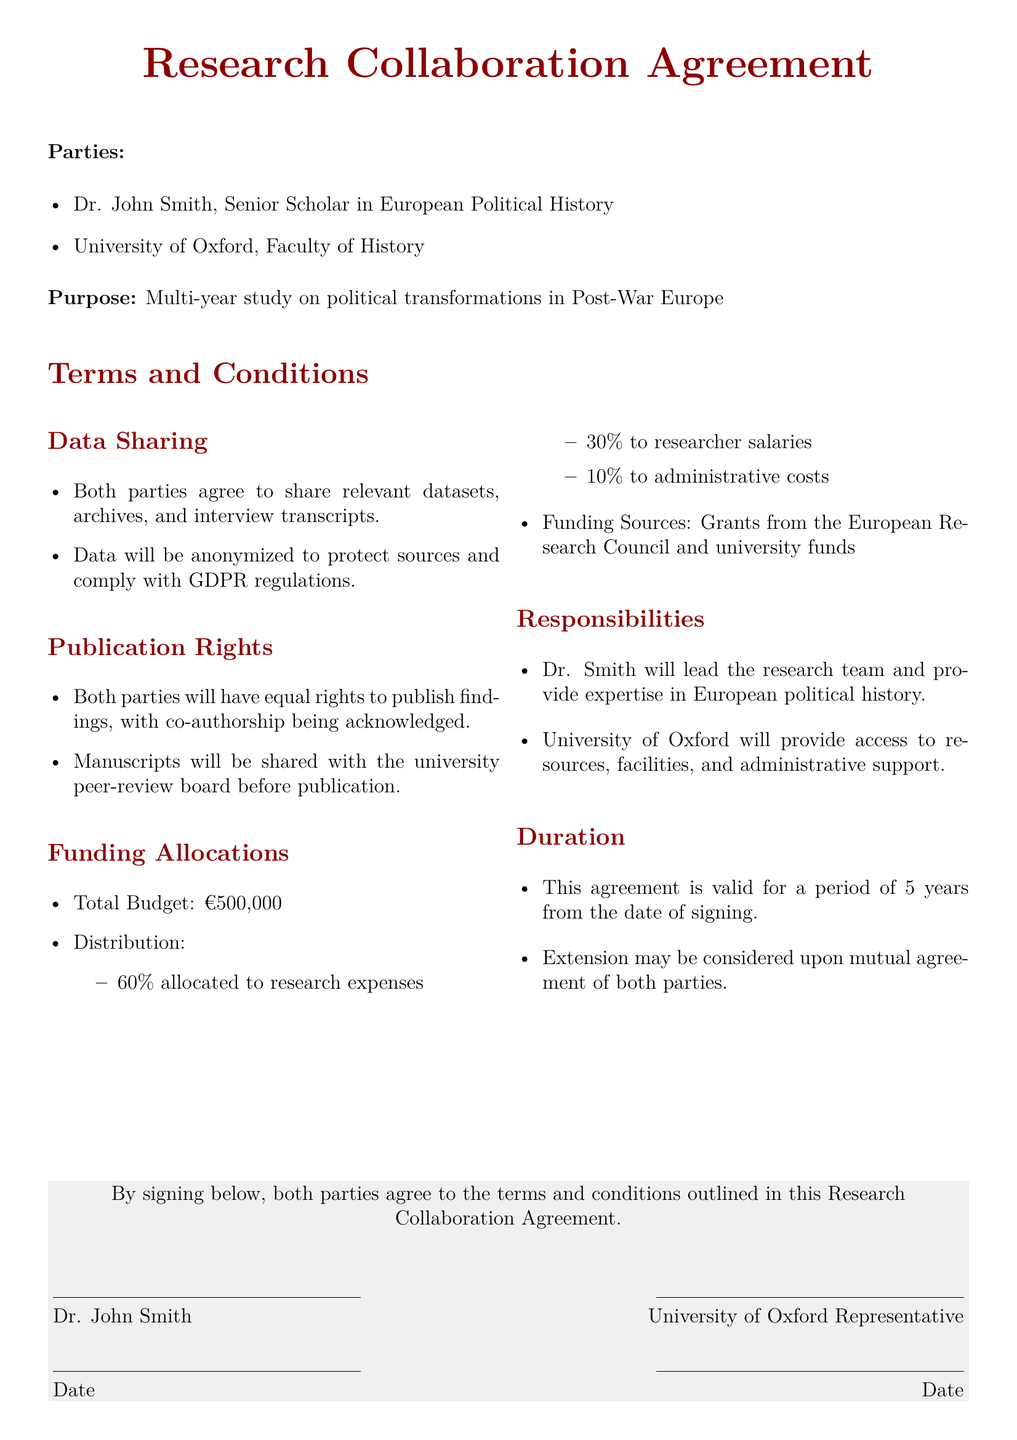What is the duration of the agreement? The agreement is valid for a period specified in the document, which is 5 years from the date of signing.
Answer: 5 years Who is the lead researcher? The document states that Dr. John Smith will lead the research team, outlining his role in the collaboration.
Answer: Dr. John Smith What is the total budget for the project? The total funding allocated for the research collaboration is detailed in the budget section of the agreement.
Answer: €500,000 What percentage of the budget is allocated to researcher salaries? The document specifies the distribution of the total budget, including what percentage is for researcher salaries.
Answer: 30% What are the funding sources mentioned in the contract? The document identifies the funding sources, indicating where the financial support is coming from.
Answer: Grants from the European Research Council and university funds What must happen before publication according to the agreement? The publication rights section indicates that manuscripts must be shared with a specific group before publication.
Answer: Peer-review board What is required for data sharing according to the contract? The data sharing section highlights a crucial requirement for protecting sensitive information while sharing data.
Answer: Anonymized What is the distribution percentage for research expenses? The agreement outlines how the total budget is divided, particularly noting the portion for research expenses.
Answer: 60% 